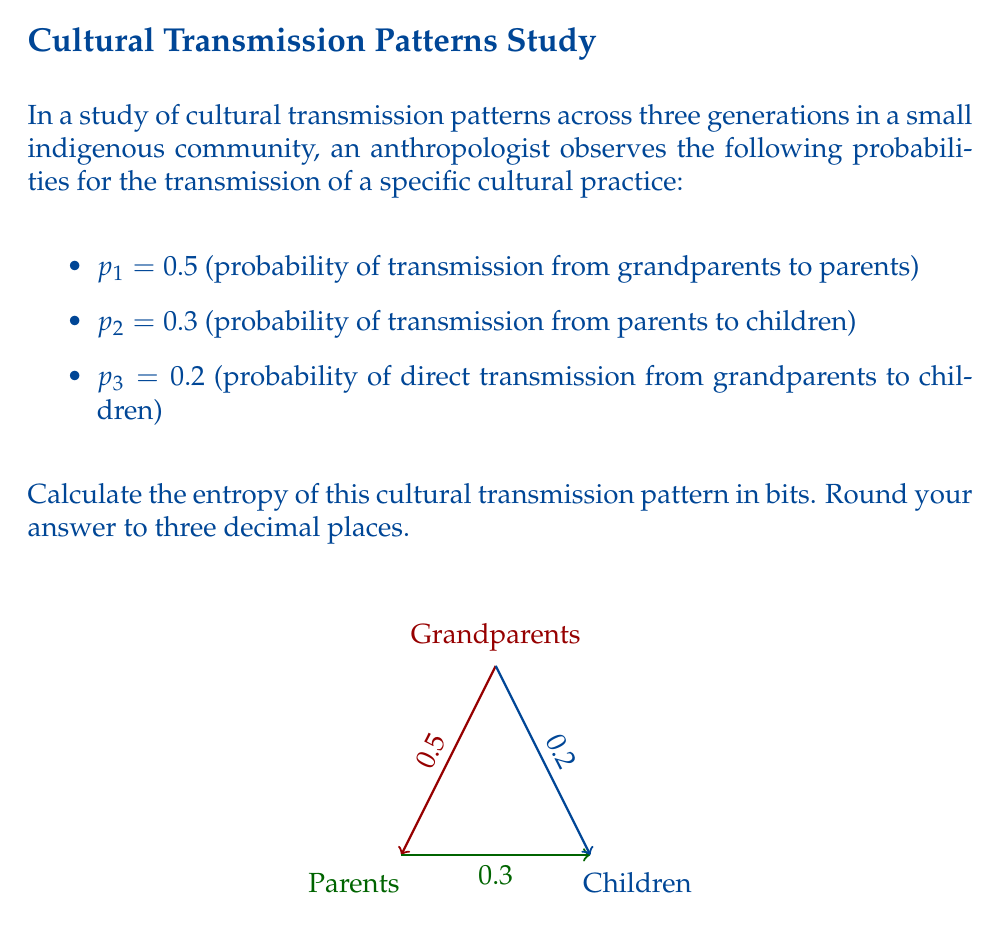Could you help me with this problem? To calculate the entropy of this cultural transmission pattern, we'll use the formula for Shannon entropy:

$$H = -\sum_{i=1}^n p_i \log_2(p_i)$$

Where $p_i$ are the probabilities of each transmission path.

Step 1: Calculate each term in the summation:
- For $p_1 = 0.5$: 
  $-0.5 \log_2(0.5) = -0.5 \times (-1) = 0.5$

- For $p_2 = 0.3$:
  $-0.3 \log_2(0.3) = -0.3 \times (-1.737) \approx 0.521$

- For $p_3 = 0.2$:
  $-0.2 \log_2(0.2) = -0.2 \times (-2.322) \approx 0.464$

Step 2: Sum up all the terms:
$H = 0.5 + 0.521 + 0.464 = 1.485$

Step 3: Round to three decimal places:
$H \approx 1.485$ bits

This entropy value represents the average amount of information or uncertainty in the cultural transmission pattern across the three generations.
Answer: 1.485 bits 